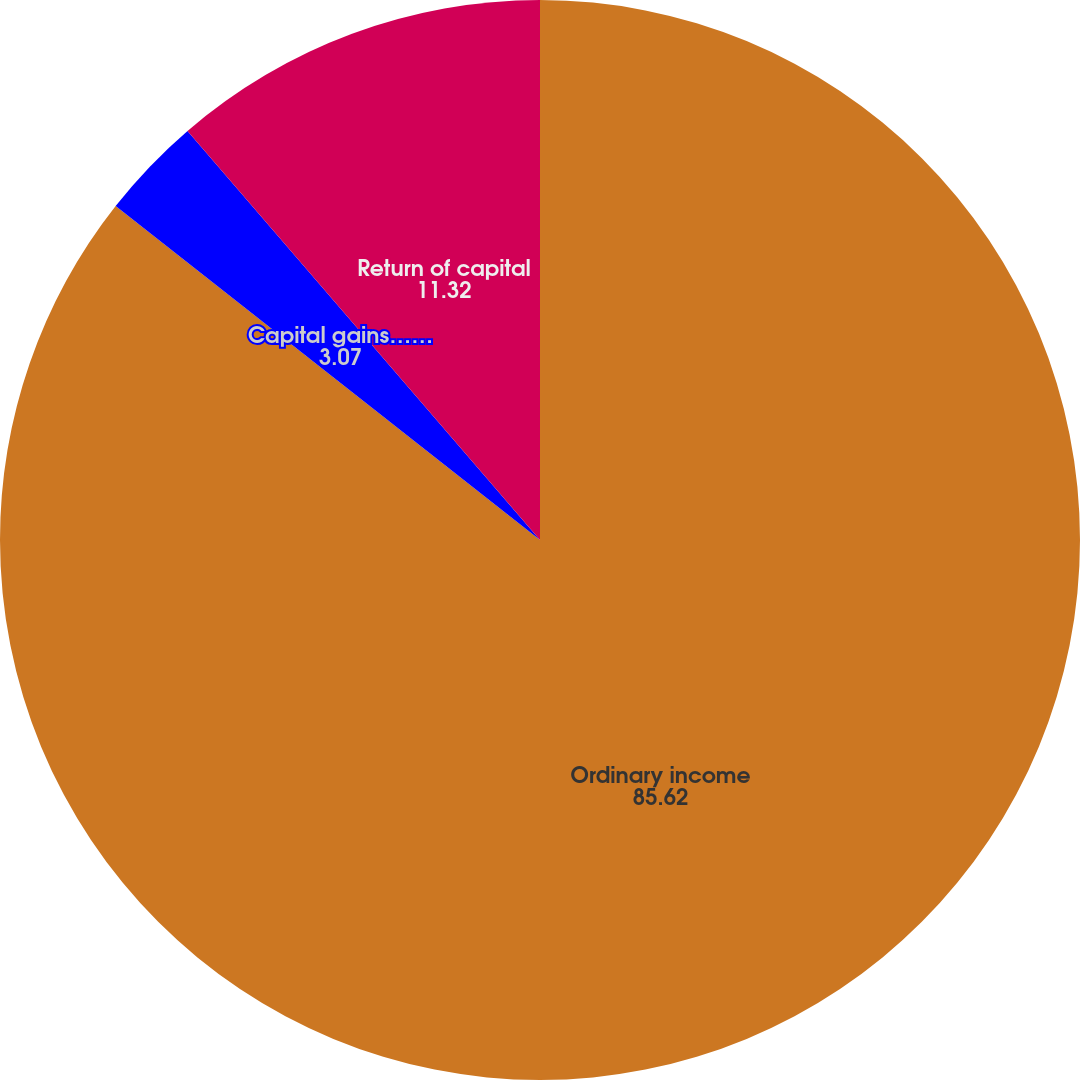Convert chart to OTSL. <chart><loc_0><loc_0><loc_500><loc_500><pie_chart><fcel>Ordinary income<fcel>Capital gains……<fcel>Return of capital<nl><fcel>85.62%<fcel>3.07%<fcel>11.32%<nl></chart> 